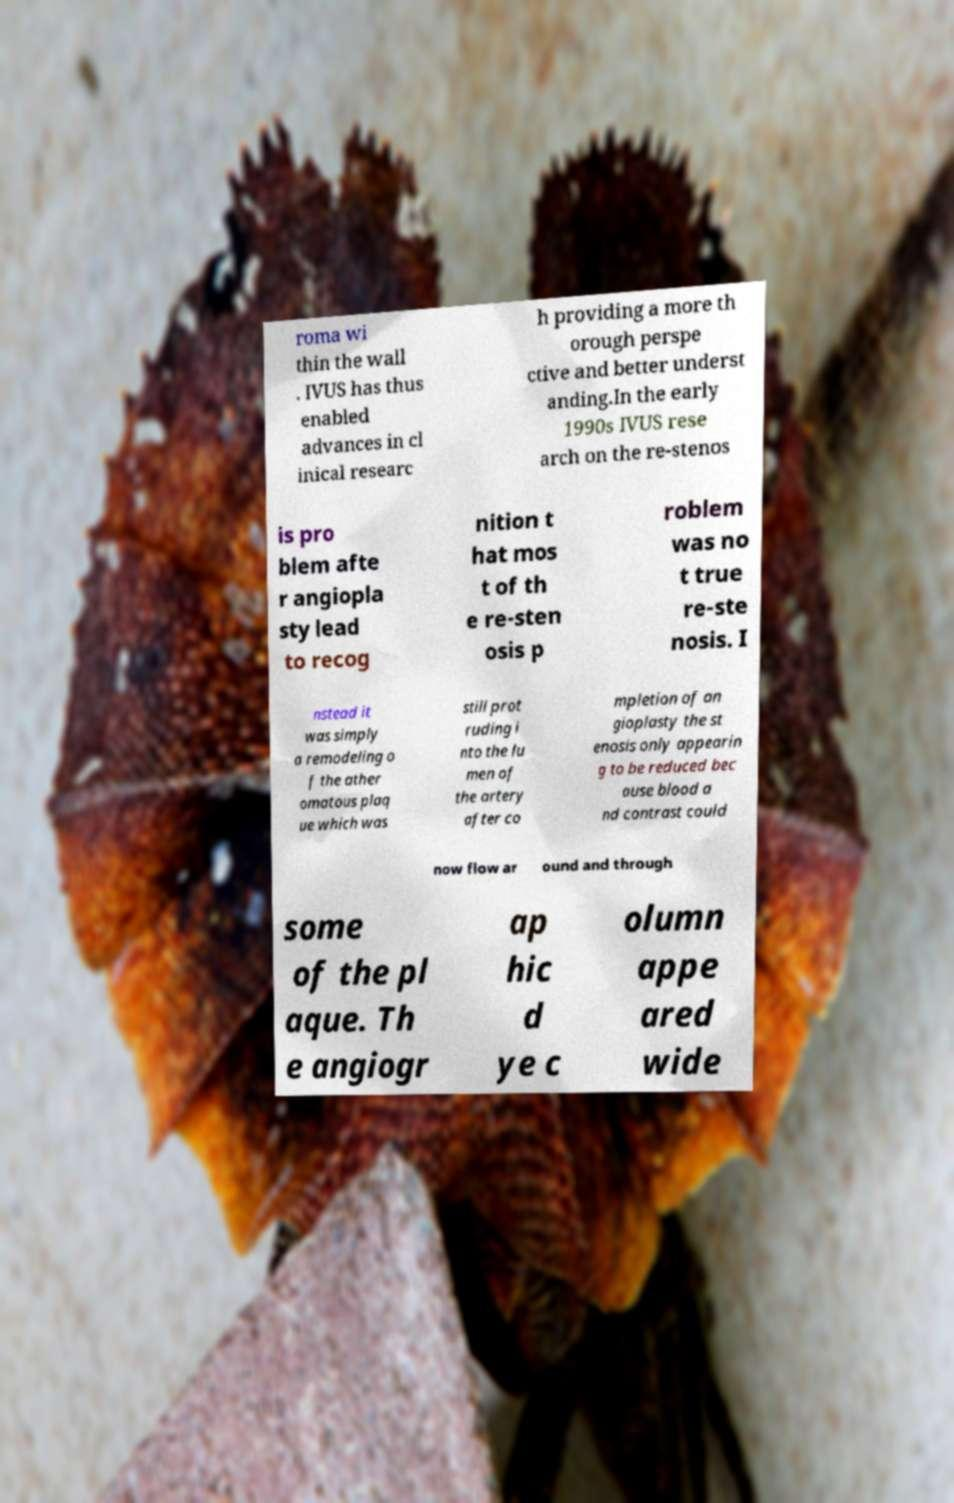Can you read and provide the text displayed in the image?This photo seems to have some interesting text. Can you extract and type it out for me? roma wi thin the wall . IVUS has thus enabled advances in cl inical researc h providing a more th orough perspe ctive and better underst anding.In the early 1990s IVUS rese arch on the re-stenos is pro blem afte r angiopla sty lead to recog nition t hat mos t of th e re-sten osis p roblem was no t true re-ste nosis. I nstead it was simply a remodeling o f the ather omatous plaq ue which was still prot ruding i nto the lu men of the artery after co mpletion of an gioplasty the st enosis only appearin g to be reduced bec ause blood a nd contrast could now flow ar ound and through some of the pl aque. Th e angiogr ap hic d ye c olumn appe ared wide 